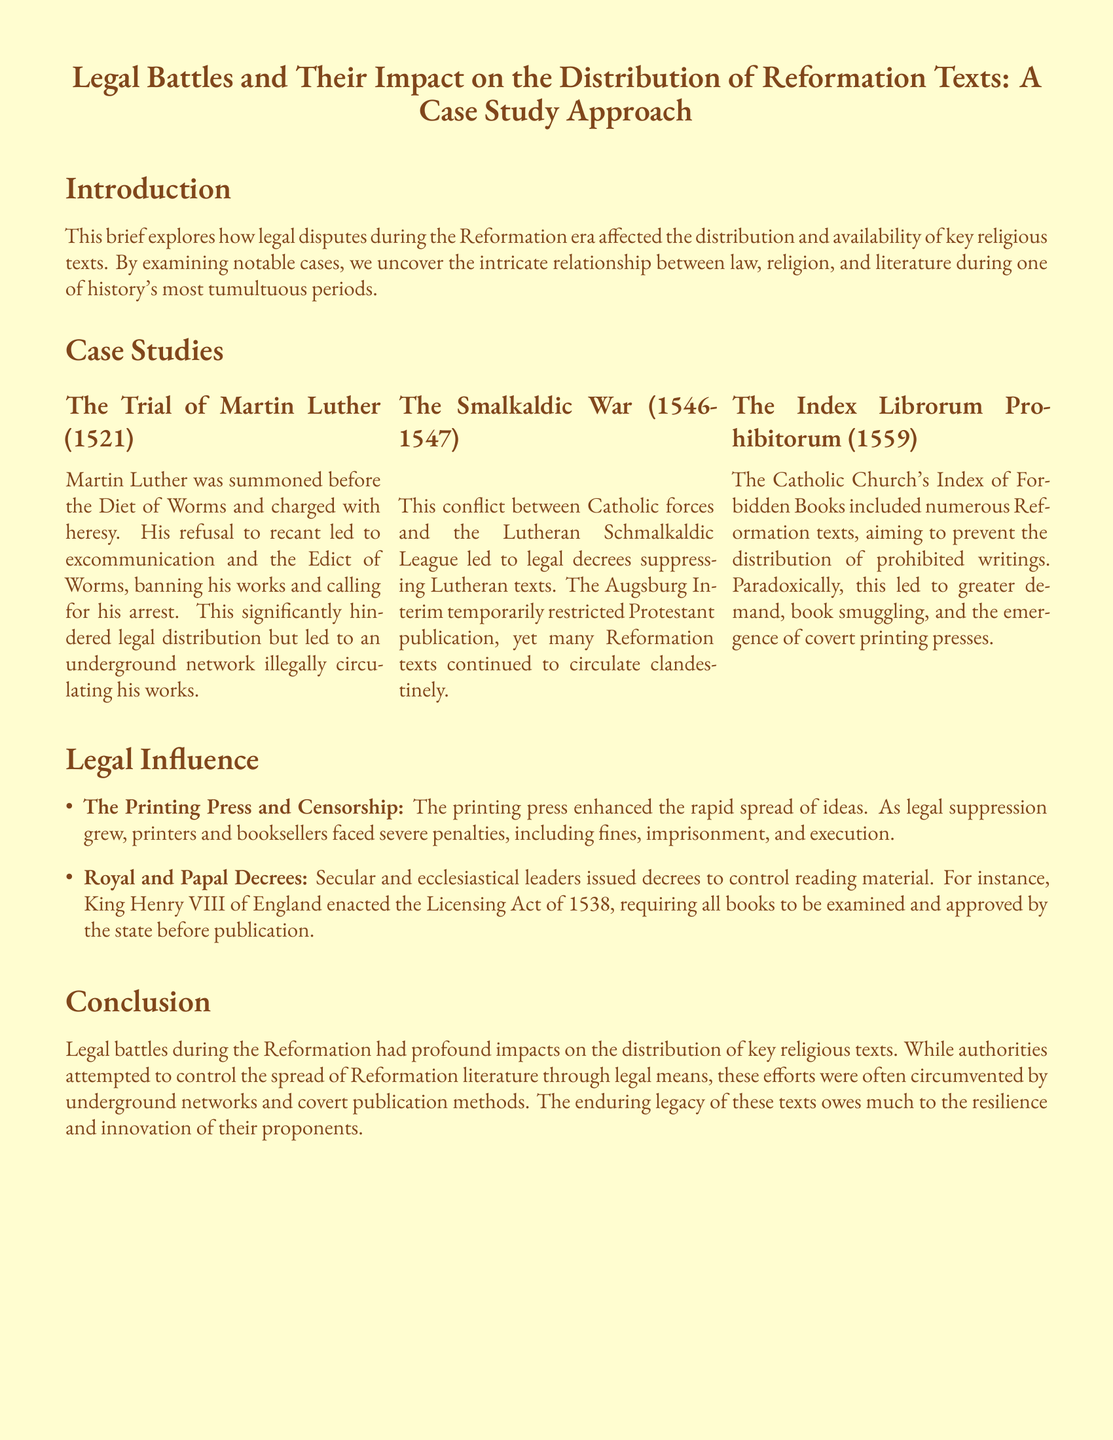What was Martin Luther charged with? Martin Luther was charged with heresy during his trial at the Diet of Worms.
Answer: heresy What did the Edict of Worms do? The Edict of Worms banned Martin Luther's works and called for his arrest.
Answer: banned his works During which conflict were legal decrees made to suppress Lutheran texts? The Smalkaldic War was when legal decrees suppressed Lutheran texts.
Answer: The Smalkaldic War What year was the Index Librorum Prohibitorum published? The Index Librorum Prohibitorum was published in 1559.
Answer: 1559 What was the consequence of the Catholic Church's Index on Reformation texts? The Index led to greater demand, book smuggling, and covert printing presses.
Answer: greater demand What did King Henry VIII's Licensing Act require? The Licensing Act required all books to be examined and approved by the state.
Answer: examination and approval How did the printing press influence the distribution of ideas? The printing press enhanced the rapid spread of ideas during the Reformation.
Answer: rapid spread What is a significant impact of legal battles on Reformation literature? Legal battles often led to underground networks for distributing literature.
Answer: underground networks What structural feature is evident in the document? The document is structured with case studies and a conclusion.
Answer: case studies and a conclusion 